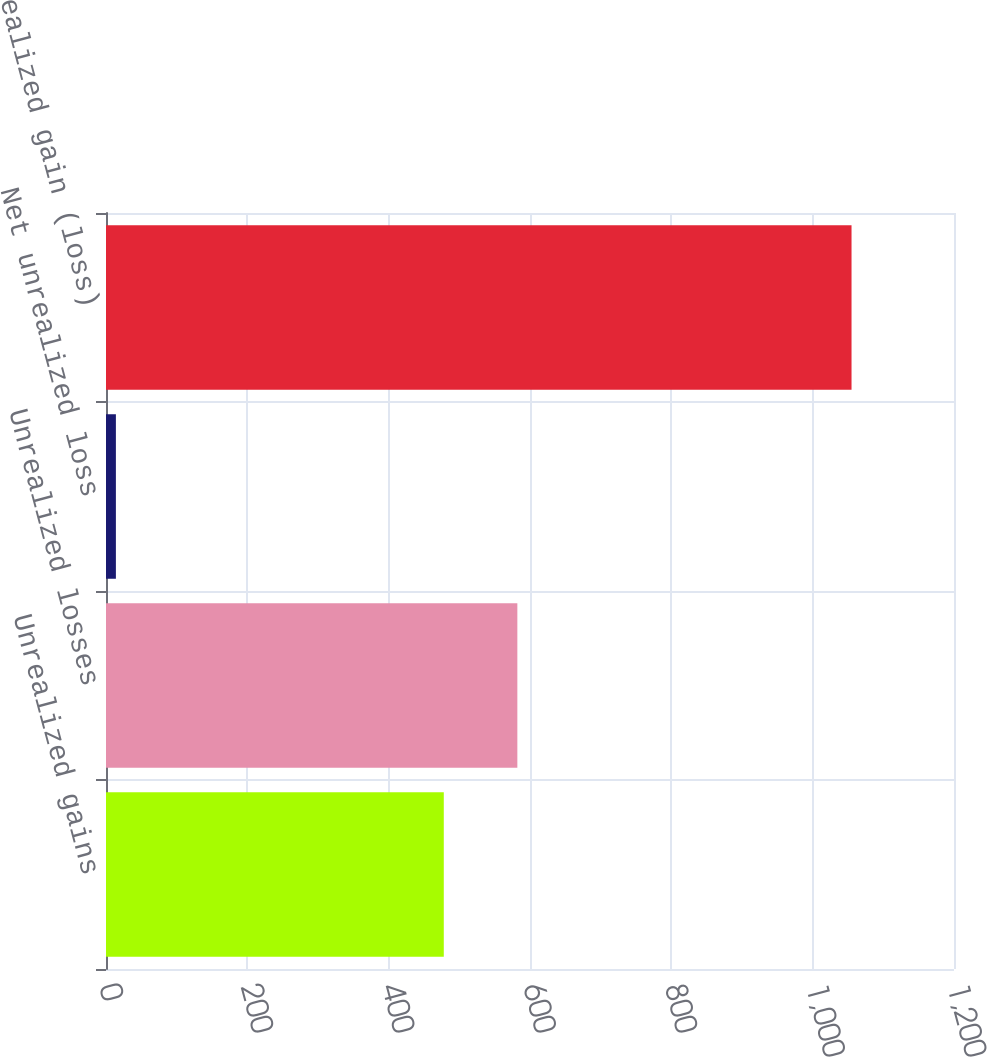<chart> <loc_0><loc_0><loc_500><loc_500><bar_chart><fcel>Unrealized gains<fcel>Unrealized losses<fcel>Net unrealized loss<fcel>Total unrealized gain (loss)<nl><fcel>478<fcel>582.1<fcel>14<fcel>1055<nl></chart> 